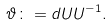Convert formula to latex. <formula><loc_0><loc_0><loc_500><loc_500>\vartheta \colon = d U U ^ { - 1 } .</formula> 